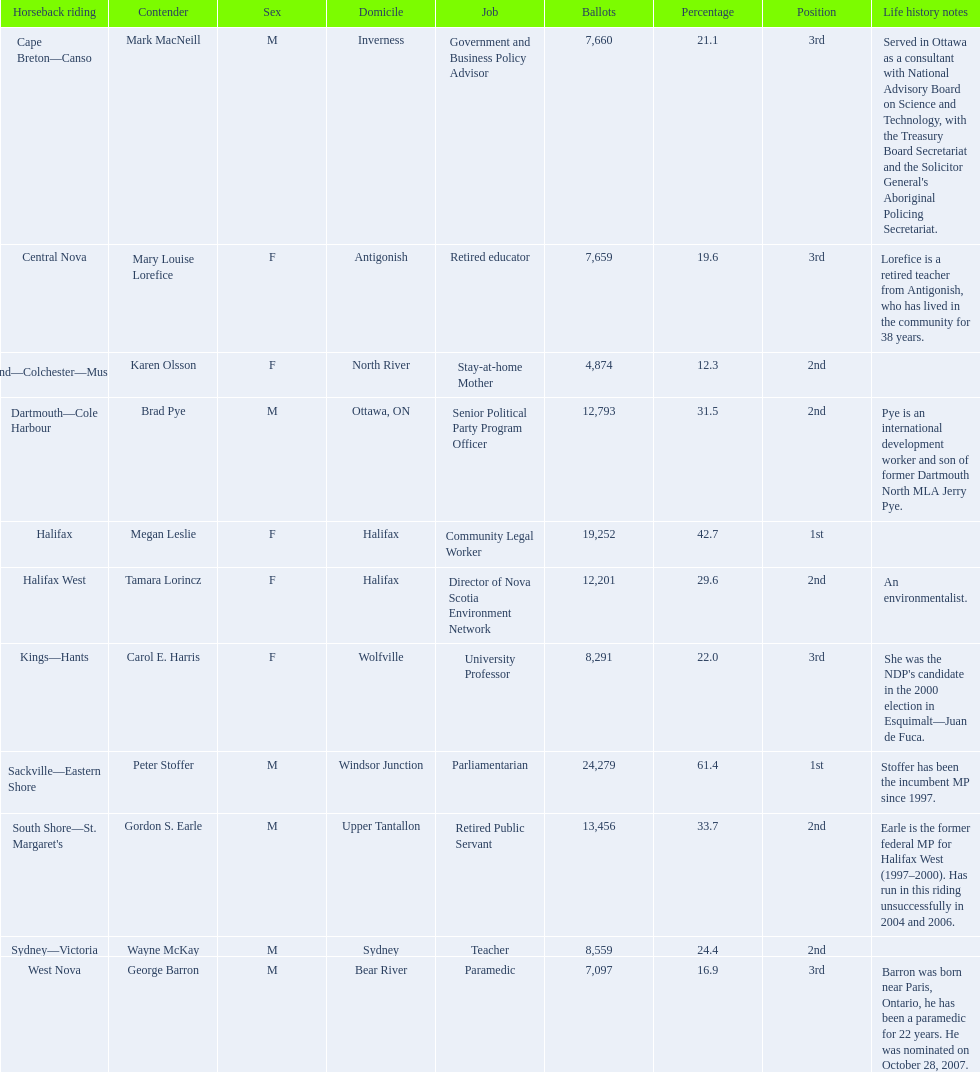What new democratic party candidates ran in the 2008 canadian federal election? Mark MacNeill, Mary Louise Lorefice, Karen Olsson, Brad Pye, Megan Leslie, Tamara Lorincz, Carol E. Harris, Peter Stoffer, Gordon S. Earle, Wayne McKay, George Barron. Of these candidates, which are female? Mary Louise Lorefice, Karen Olsson, Megan Leslie, Tamara Lorincz, Carol E. Harris. Which of these candidates resides in halifax? Megan Leslie, Tamara Lorincz. Of the remaining two, which was ranked 1st? Megan Leslie. How many votes did she get? 19,252. 